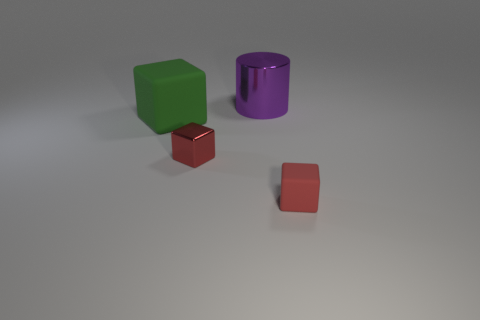Does the small matte cube have the same color as the tiny cube that is left of the big metal cylinder?
Make the answer very short. Yes. How many objects are either purple metallic cylinders that are behind the small metallic object or large objects on the right side of the green thing?
Offer a terse response. 1. The object that is behind the matte object behind the tiny metal cube is what shape?
Provide a short and direct response. Cylinder. Is there another big object made of the same material as the large purple object?
Offer a very short reply. No. There is a tiny metal thing that is the same shape as the big green thing; what is its color?
Provide a short and direct response. Red. Is the number of small red rubber things that are behind the purple thing less than the number of large green rubber things that are on the left side of the small red metallic cube?
Offer a very short reply. Yes. How many other objects are the same shape as the large shiny thing?
Your answer should be compact. 0. Is the number of green matte things that are on the right side of the tiny matte cube less than the number of small blue things?
Your response must be concise. No. What is the material of the red block left of the large shiny thing?
Give a very brief answer. Metal. How many other objects are there of the same size as the purple metal cylinder?
Ensure brevity in your answer.  1. 